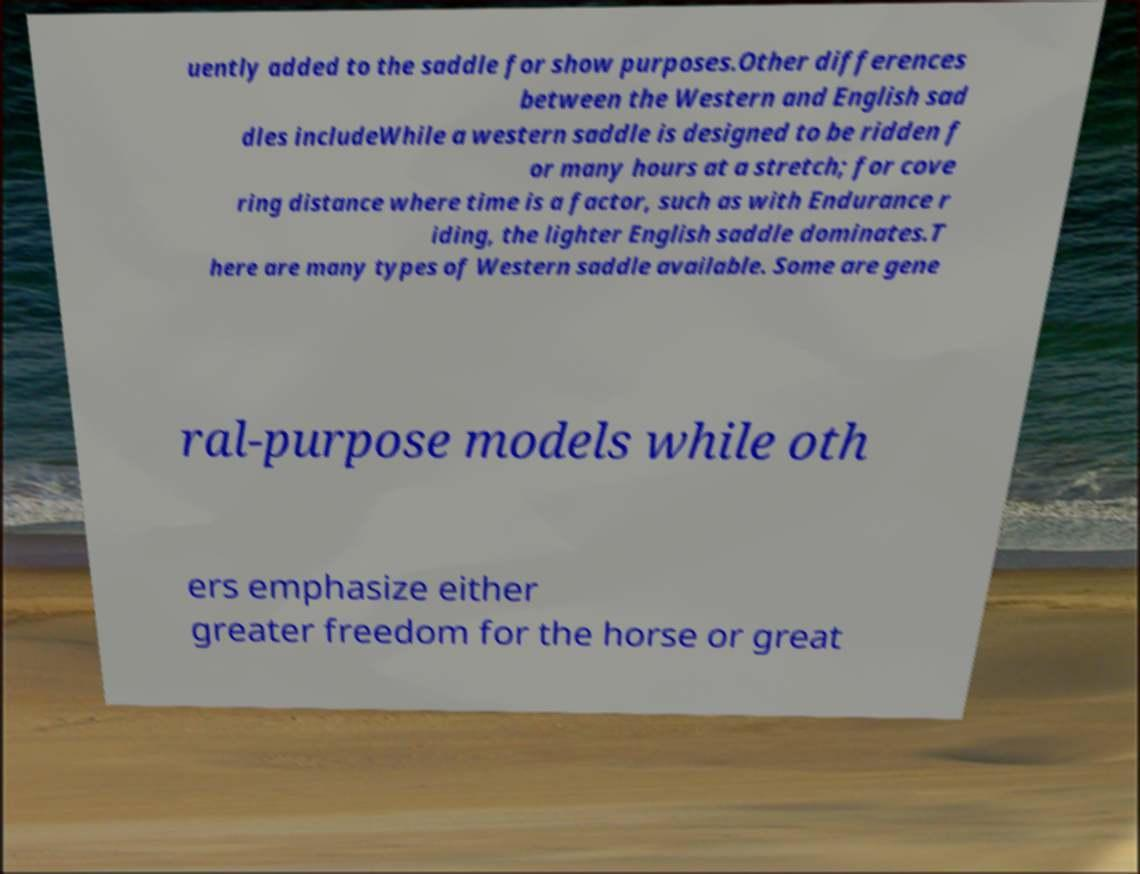Please identify and transcribe the text found in this image. uently added to the saddle for show purposes.Other differences between the Western and English sad dles includeWhile a western saddle is designed to be ridden f or many hours at a stretch; for cove ring distance where time is a factor, such as with Endurance r iding, the lighter English saddle dominates.T here are many types of Western saddle available. Some are gene ral-purpose models while oth ers emphasize either greater freedom for the horse or great 